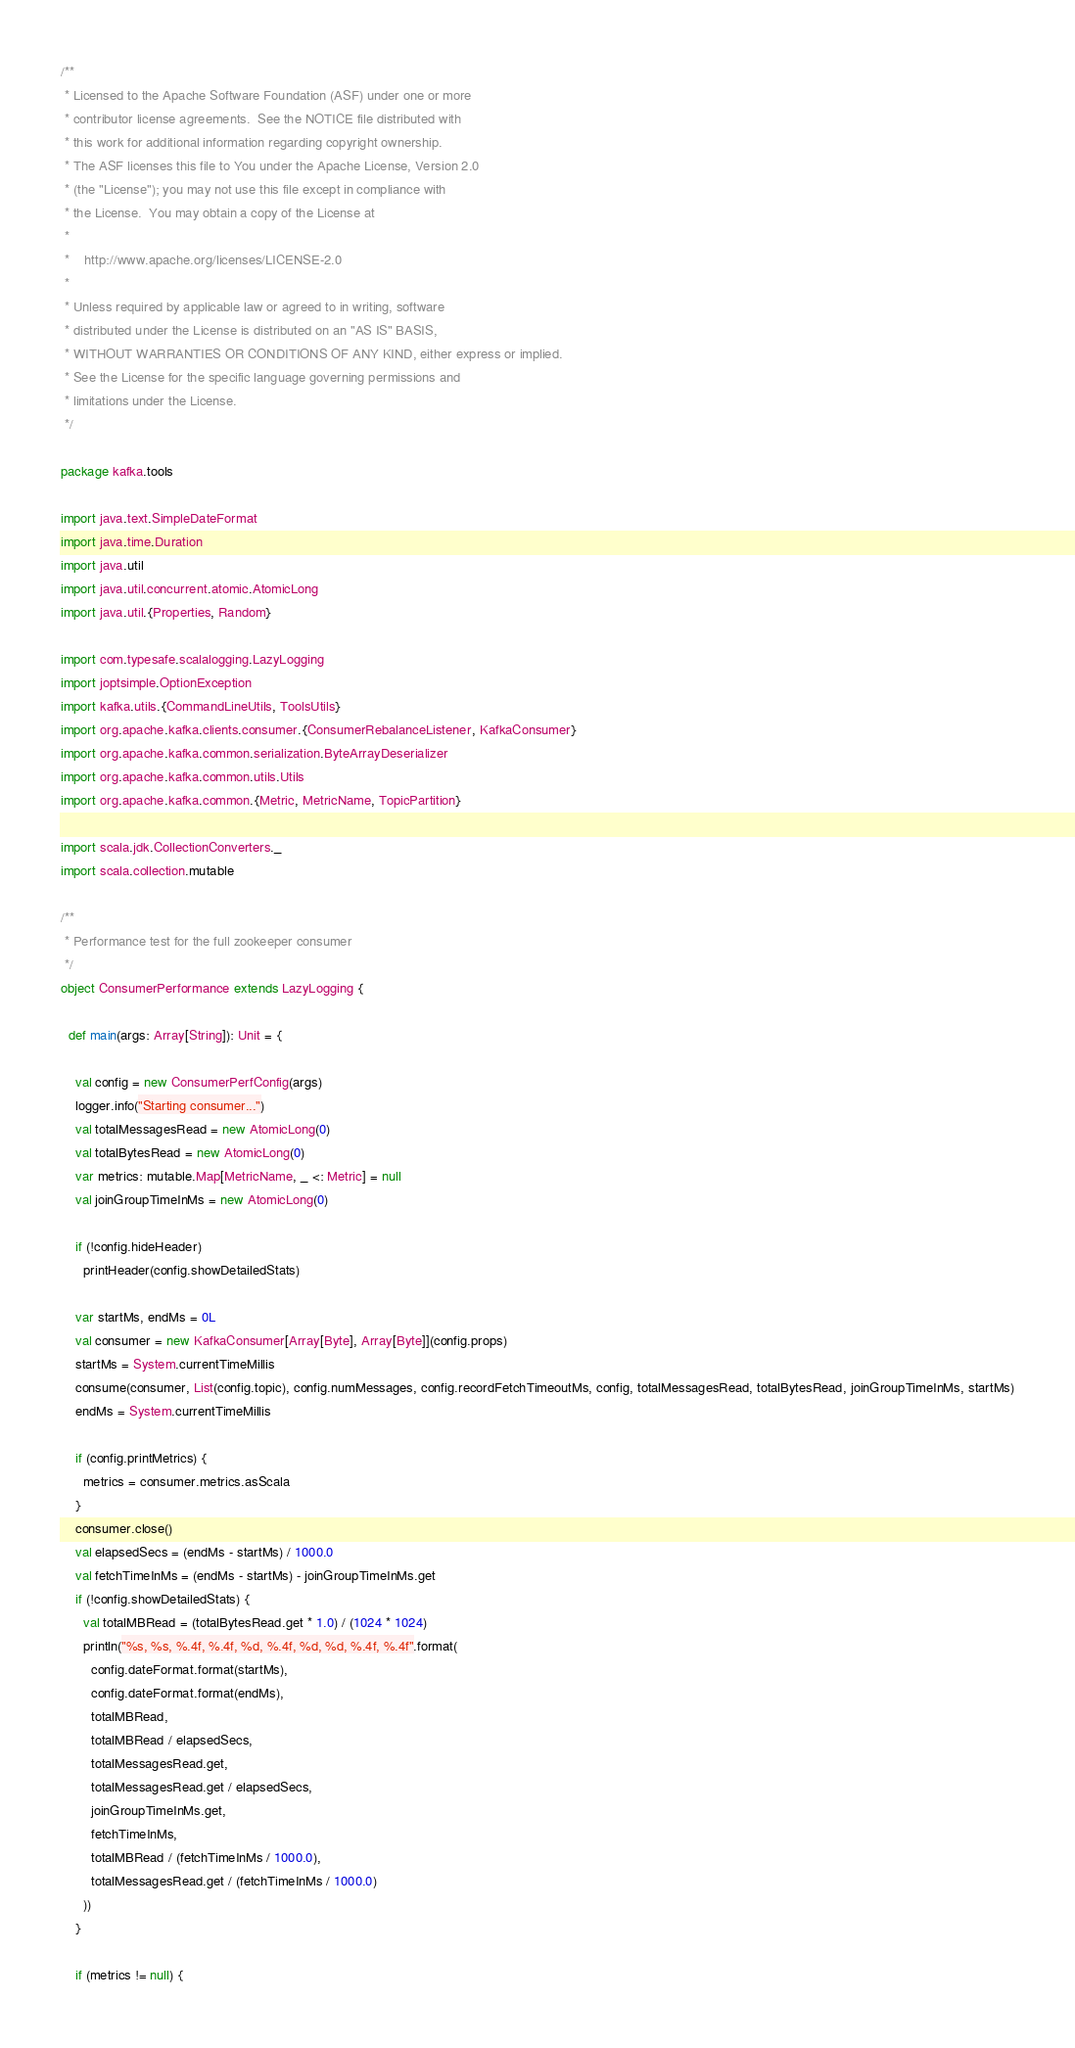<code> <loc_0><loc_0><loc_500><loc_500><_Scala_>/**
 * Licensed to the Apache Software Foundation (ASF) under one or more
 * contributor license agreements.  See the NOTICE file distributed with
 * this work for additional information regarding copyright ownership.
 * The ASF licenses this file to You under the Apache License, Version 2.0
 * (the "License"); you may not use this file except in compliance with
 * the License.  You may obtain a copy of the License at
 *
 *    http://www.apache.org/licenses/LICENSE-2.0
 *
 * Unless required by applicable law or agreed to in writing, software
 * distributed under the License is distributed on an "AS IS" BASIS,
 * WITHOUT WARRANTIES OR CONDITIONS OF ANY KIND, either express or implied.
 * See the License for the specific language governing permissions and
 * limitations under the License.
 */

package kafka.tools

import java.text.SimpleDateFormat
import java.time.Duration
import java.util
import java.util.concurrent.atomic.AtomicLong
import java.util.{Properties, Random}

import com.typesafe.scalalogging.LazyLogging
import joptsimple.OptionException
import kafka.utils.{CommandLineUtils, ToolsUtils}
import org.apache.kafka.clients.consumer.{ConsumerRebalanceListener, KafkaConsumer}
import org.apache.kafka.common.serialization.ByteArrayDeserializer
import org.apache.kafka.common.utils.Utils
import org.apache.kafka.common.{Metric, MetricName, TopicPartition}

import scala.jdk.CollectionConverters._
import scala.collection.mutable

/**
 * Performance test for the full zookeeper consumer
 */
object ConsumerPerformance extends LazyLogging {

  def main(args: Array[String]): Unit = {

    val config = new ConsumerPerfConfig(args)
    logger.info("Starting consumer...")
    val totalMessagesRead = new AtomicLong(0)
    val totalBytesRead = new AtomicLong(0)
    var metrics: mutable.Map[MetricName, _ <: Metric] = null
    val joinGroupTimeInMs = new AtomicLong(0)

    if (!config.hideHeader)
      printHeader(config.showDetailedStats)

    var startMs, endMs = 0L
    val consumer = new KafkaConsumer[Array[Byte], Array[Byte]](config.props)
    startMs = System.currentTimeMillis
    consume(consumer, List(config.topic), config.numMessages, config.recordFetchTimeoutMs, config, totalMessagesRead, totalBytesRead, joinGroupTimeInMs, startMs)
    endMs = System.currentTimeMillis

    if (config.printMetrics) {
      metrics = consumer.metrics.asScala
    }
    consumer.close()
    val elapsedSecs = (endMs - startMs) / 1000.0
    val fetchTimeInMs = (endMs - startMs) - joinGroupTimeInMs.get
    if (!config.showDetailedStats) {
      val totalMBRead = (totalBytesRead.get * 1.0) / (1024 * 1024)
      println("%s, %s, %.4f, %.4f, %d, %.4f, %d, %d, %.4f, %.4f".format(
        config.dateFormat.format(startMs),
        config.dateFormat.format(endMs),
        totalMBRead,
        totalMBRead / elapsedSecs,
        totalMessagesRead.get,
        totalMessagesRead.get / elapsedSecs,
        joinGroupTimeInMs.get,
        fetchTimeInMs,
        totalMBRead / (fetchTimeInMs / 1000.0),
        totalMessagesRead.get / (fetchTimeInMs / 1000.0)
      ))
    }

    if (metrics != null) {</code> 